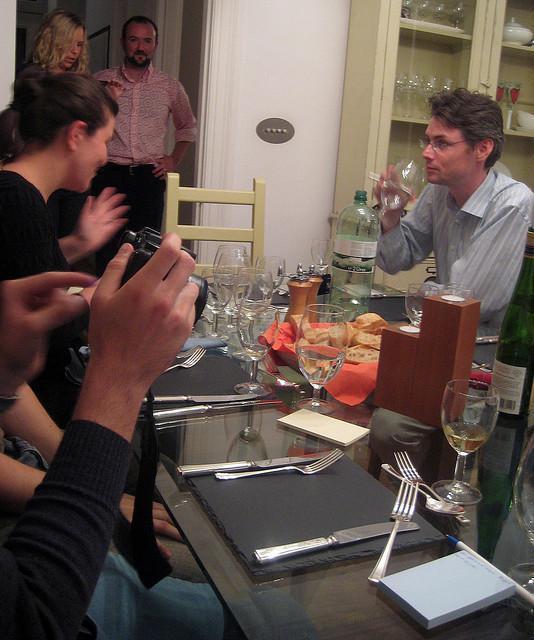How many red wines glasses are on the table?
Give a very brief answer. 0. How many people are wearing glasses?
Give a very brief answer. 1. How many wine glasses are there?
Give a very brief answer. 3. How many people are visible?
Give a very brief answer. 5. How many bottles can be seen?
Give a very brief answer. 2. How many books are there?
Give a very brief answer. 1. How many people on the train are sitting next to a window that opens?
Give a very brief answer. 0. 